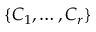<formula> <loc_0><loc_0><loc_500><loc_500>\{ C _ { 1 } , \dots , C _ { r } \}</formula> 